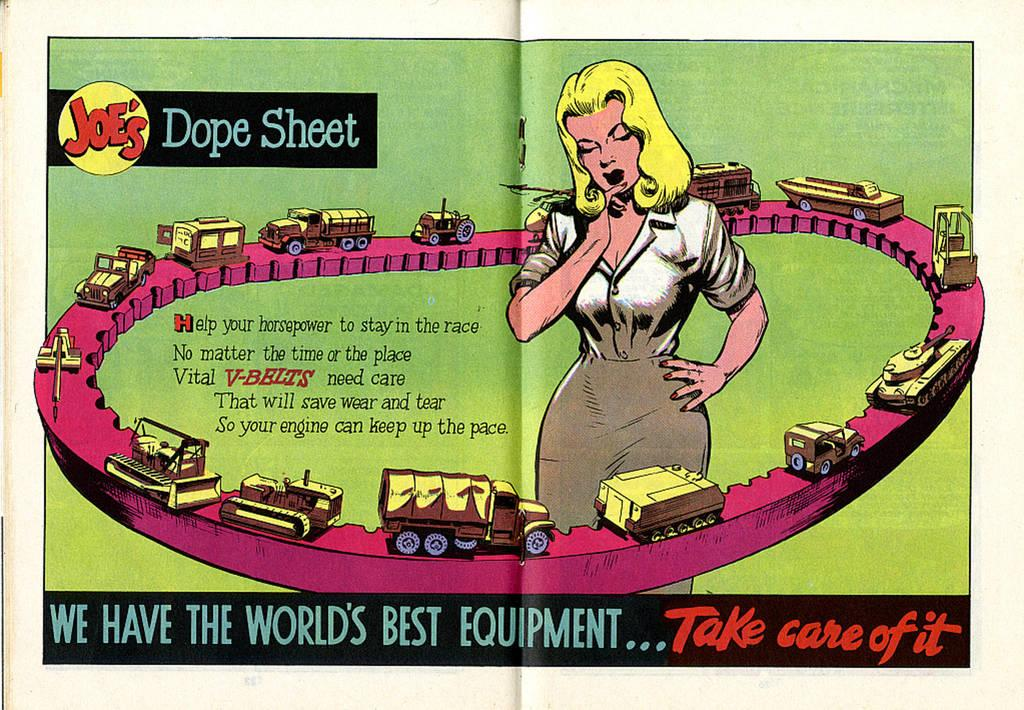<image>
Relay a brief, clear account of the picture shown. two page ad labeled joe's dope sheet that tells about v-belts 